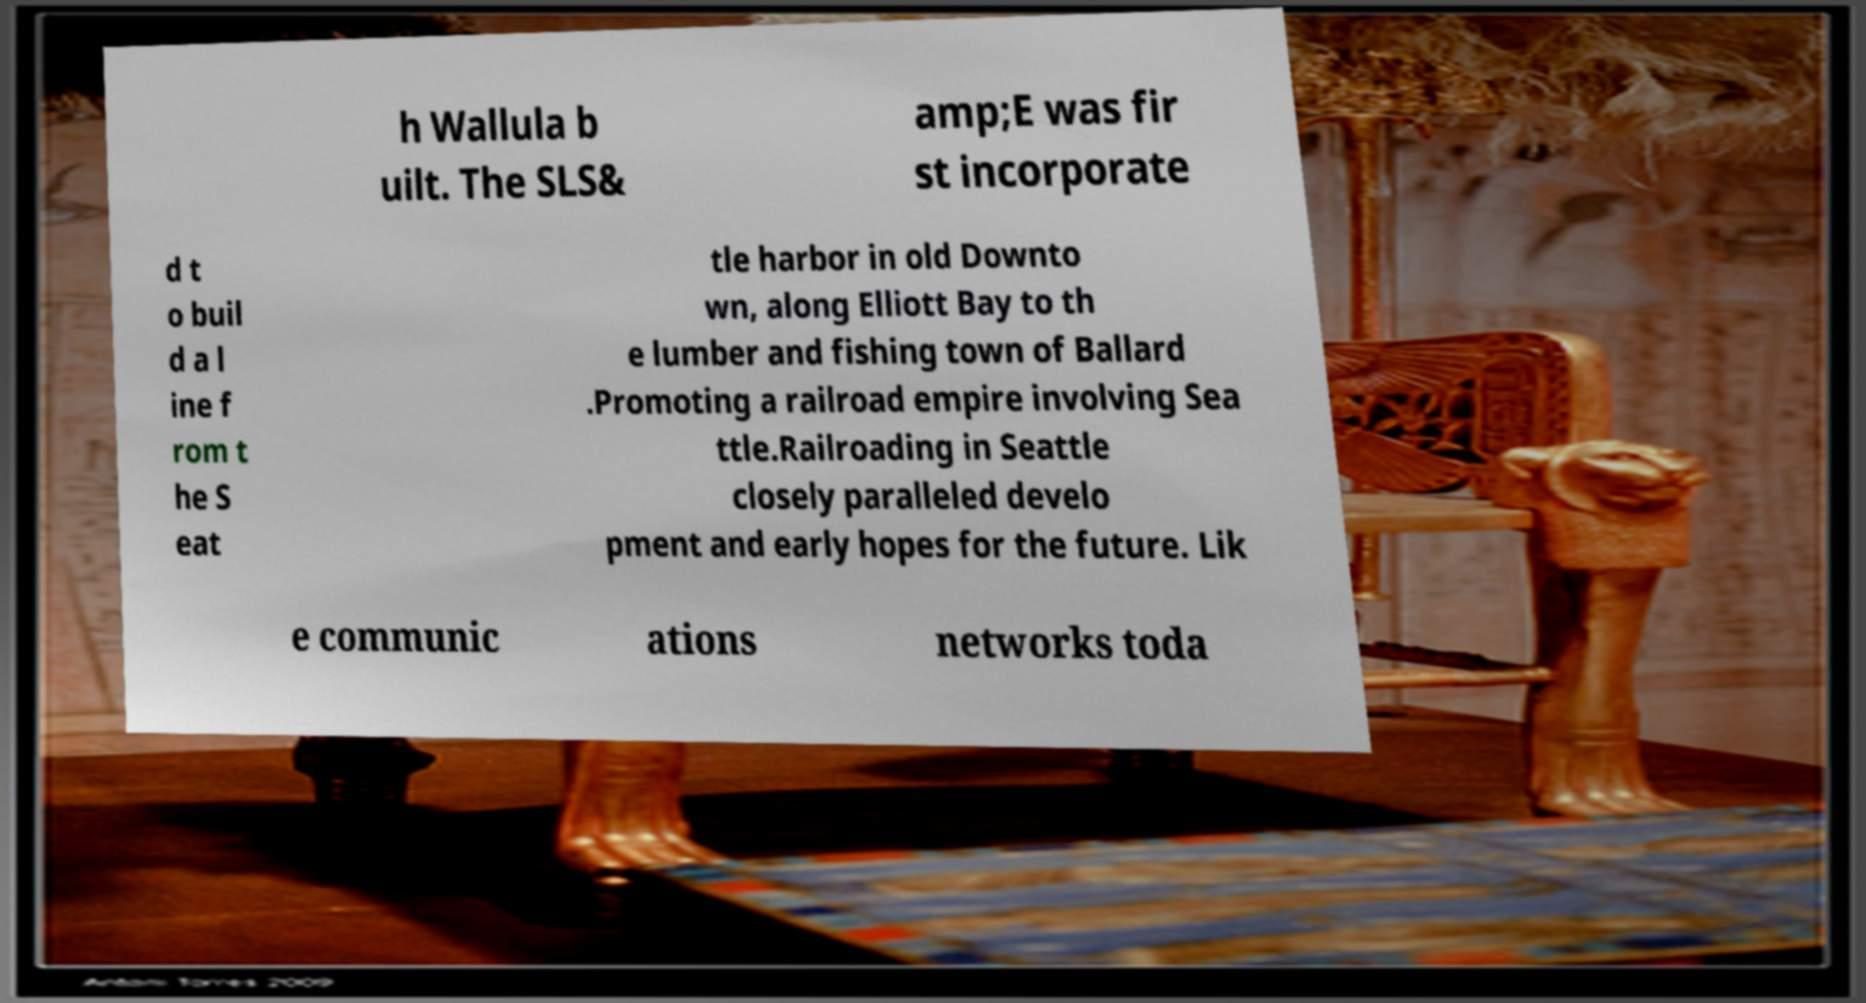What messages or text are displayed in this image? I need them in a readable, typed format. h Wallula b uilt. The SLS& amp;E was fir st incorporate d t o buil d a l ine f rom t he S eat tle harbor in old Downto wn, along Elliott Bay to th e lumber and fishing town of Ballard .Promoting a railroad empire involving Sea ttle.Railroading in Seattle closely paralleled develo pment and early hopes for the future. Lik e communic ations networks toda 